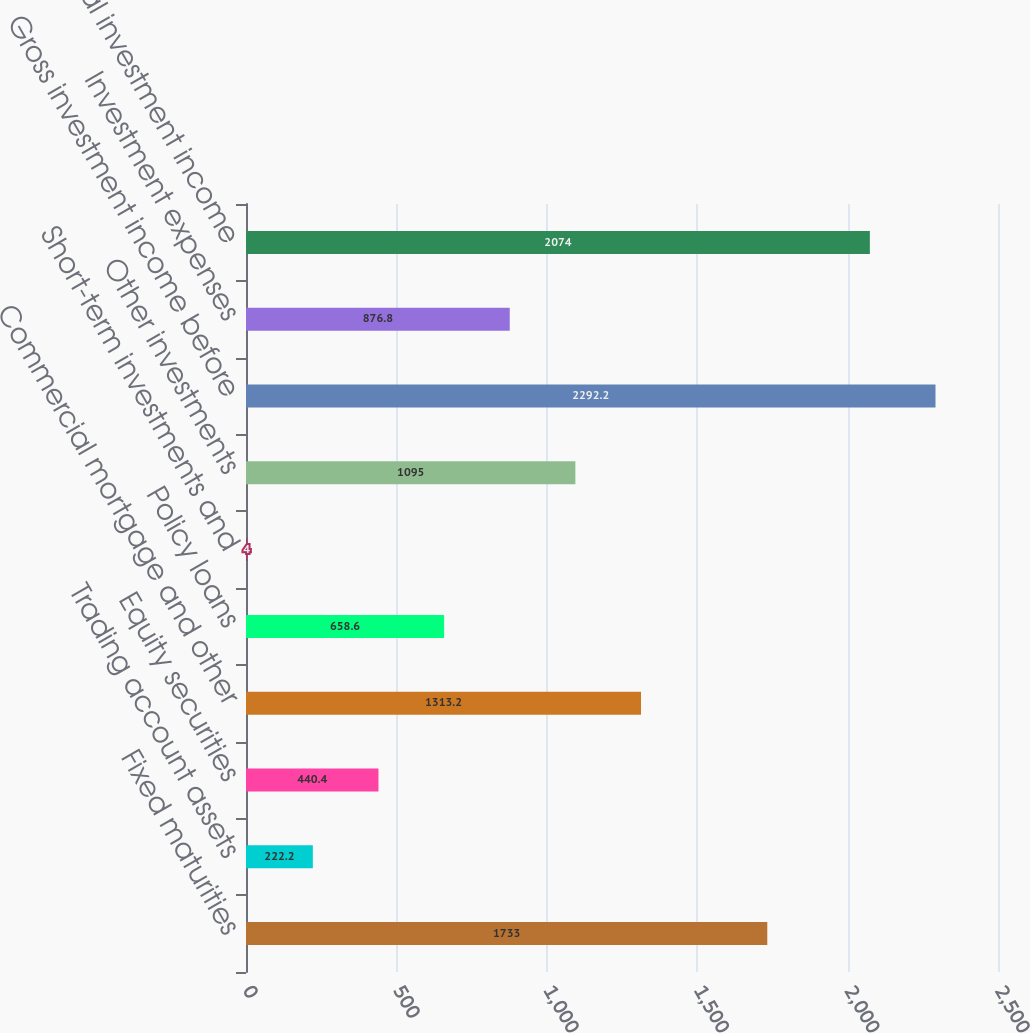<chart> <loc_0><loc_0><loc_500><loc_500><bar_chart><fcel>Fixed maturities<fcel>Trading account assets<fcel>Equity securities<fcel>Commercial mortgage and other<fcel>Policy loans<fcel>Short-term investments and<fcel>Other investments<fcel>Gross investment income before<fcel>Investment expenses<fcel>Total investment income<nl><fcel>1733<fcel>222.2<fcel>440.4<fcel>1313.2<fcel>658.6<fcel>4<fcel>1095<fcel>2292.2<fcel>876.8<fcel>2074<nl></chart> 